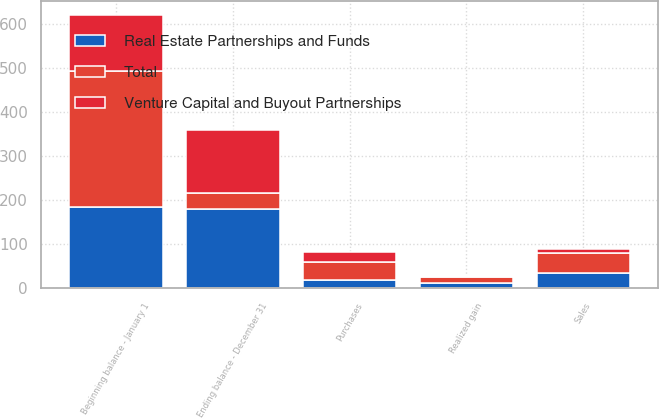Convert chart to OTSL. <chart><loc_0><loc_0><loc_500><loc_500><stacked_bar_chart><ecel><fcel>Beginning balance - January 1<fcel>Realized gain<fcel>Purchases<fcel>Sales<fcel>Ending balance - December 31<nl><fcel>Real Estate Partnerships and Funds<fcel>184<fcel>11<fcel>18<fcel>35<fcel>179<nl><fcel>Venture Capital and Buyout Partnerships<fcel>126<fcel>3<fcel>23<fcel>9<fcel>143<nl><fcel>Total<fcel>310<fcel>14<fcel>41<fcel>44<fcel>38<nl></chart> 